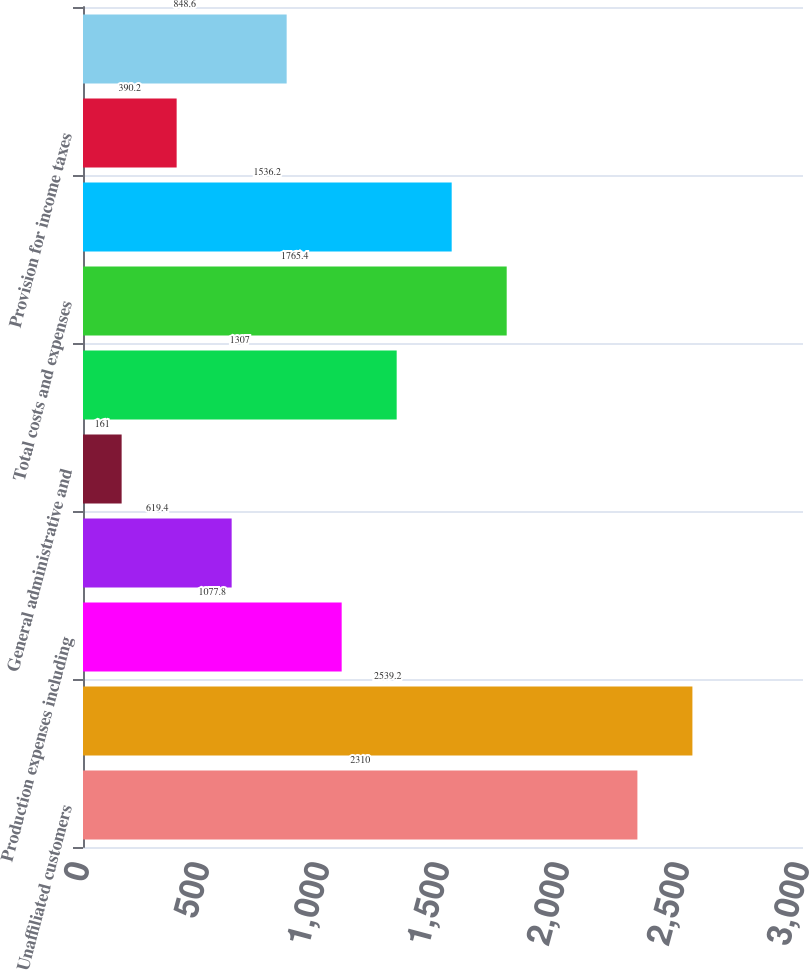<chart> <loc_0><loc_0><loc_500><loc_500><bar_chart><fcel>Unaffiliated customers<fcel>Total revenues<fcel>Production expenses including<fcel>Exploration expenses including<fcel>General administrative and<fcel>Depreciation depletion and<fcel>Total costs and expenses<fcel>Results of operations before<fcel>Provision for income taxes<fcel>Results of operations<nl><fcel>2310<fcel>2539.2<fcel>1077.8<fcel>619.4<fcel>161<fcel>1307<fcel>1765.4<fcel>1536.2<fcel>390.2<fcel>848.6<nl></chart> 